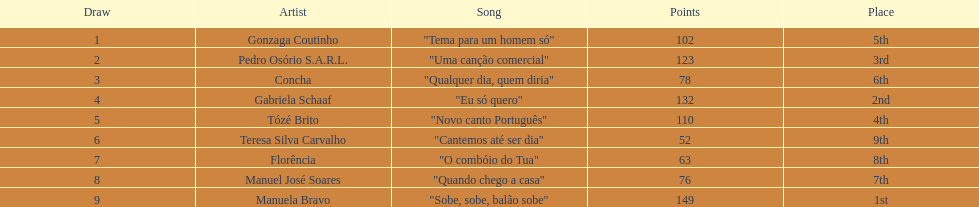Who sang "eu só quero" as their song in the eurovision song contest of 1979? Gabriela Schaaf. 